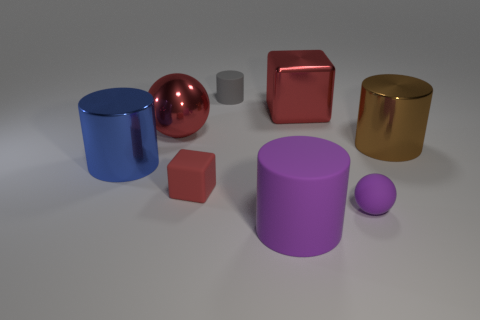Can you describe the arrangement and colors of the objects seen in the image? Certainly! The image showcases a collection of geometric shapes scattered across a surface. From left to right, we see a large blue cylinder, a reflective red sphere, a smaller grey cylinder, a small red cube, a shiny golden cylinder, a purple cylinder, and a small purple sphere. The background is neutral, which allows the vibrant colors of the shapes to stand out prominently. 